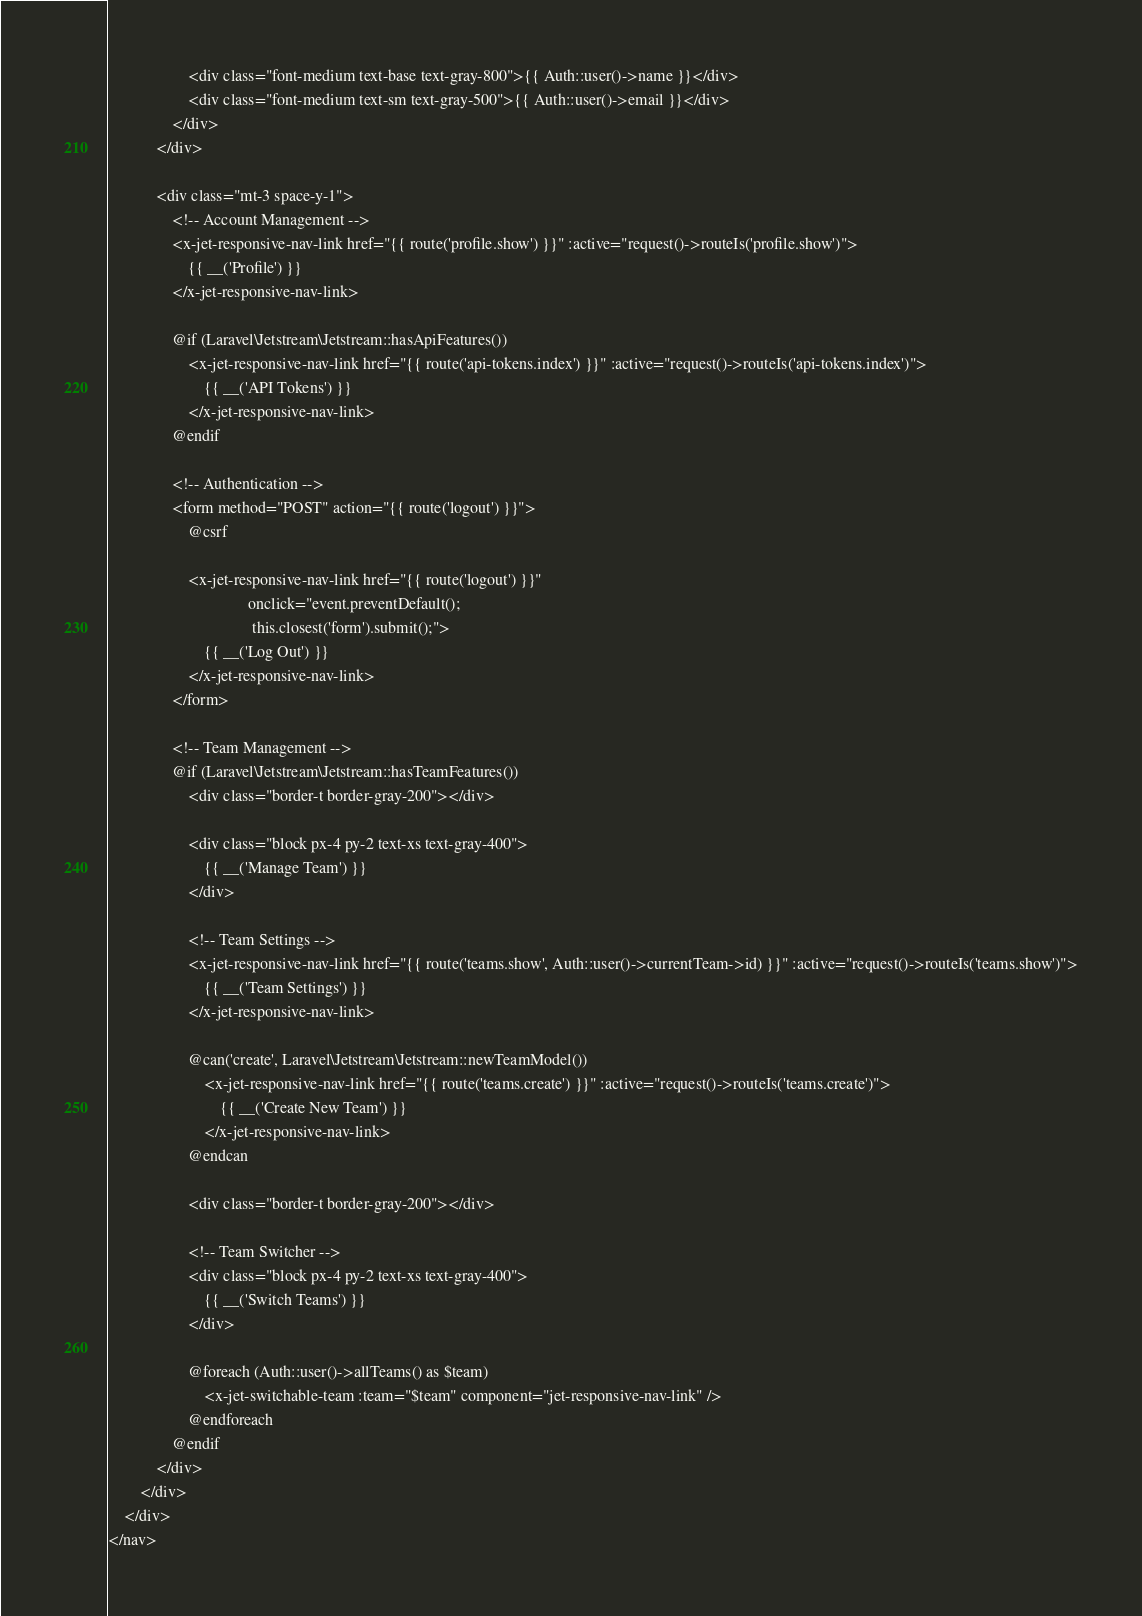Convert code to text. <code><loc_0><loc_0><loc_500><loc_500><_PHP_>                    <div class="font-medium text-base text-gray-800">{{ Auth::user()->name }}</div>
                    <div class="font-medium text-sm text-gray-500">{{ Auth::user()->email }}</div>
                </div>
            </div>

            <div class="mt-3 space-y-1">
                <!-- Account Management -->
                <x-jet-responsive-nav-link href="{{ route('profile.show') }}" :active="request()->routeIs('profile.show')">
                    {{ __('Profile') }}
                </x-jet-responsive-nav-link>

                @if (Laravel\Jetstream\Jetstream::hasApiFeatures())
                    <x-jet-responsive-nav-link href="{{ route('api-tokens.index') }}" :active="request()->routeIs('api-tokens.index')">
                        {{ __('API Tokens') }}
                    </x-jet-responsive-nav-link>
                @endif

                <!-- Authentication -->
                <form method="POST" action="{{ route('logout') }}">
                    @csrf

                    <x-jet-responsive-nav-link href="{{ route('logout') }}"
                                   onclick="event.preventDefault();
                                    this.closest('form').submit();">
                        {{ __('Log Out') }}
                    </x-jet-responsive-nav-link>
                </form>

                <!-- Team Management -->
                @if (Laravel\Jetstream\Jetstream::hasTeamFeatures())
                    <div class="border-t border-gray-200"></div>

                    <div class="block px-4 py-2 text-xs text-gray-400">
                        {{ __('Manage Team') }}
                    </div>

                    <!-- Team Settings -->
                    <x-jet-responsive-nav-link href="{{ route('teams.show', Auth::user()->currentTeam->id) }}" :active="request()->routeIs('teams.show')">
                        {{ __('Team Settings') }}
                    </x-jet-responsive-nav-link>

                    @can('create', Laravel\Jetstream\Jetstream::newTeamModel())
                        <x-jet-responsive-nav-link href="{{ route('teams.create') }}" :active="request()->routeIs('teams.create')">
                            {{ __('Create New Team') }}
                        </x-jet-responsive-nav-link>
                    @endcan

                    <div class="border-t border-gray-200"></div>

                    <!-- Team Switcher -->
                    <div class="block px-4 py-2 text-xs text-gray-400">
                        {{ __('Switch Teams') }}
                    </div>

                    @foreach (Auth::user()->allTeams() as $team)
                        <x-jet-switchable-team :team="$team" component="jet-responsive-nav-link" />
                    @endforeach
                @endif
            </div>
        </div>
    </div>
</nav>
</code> 